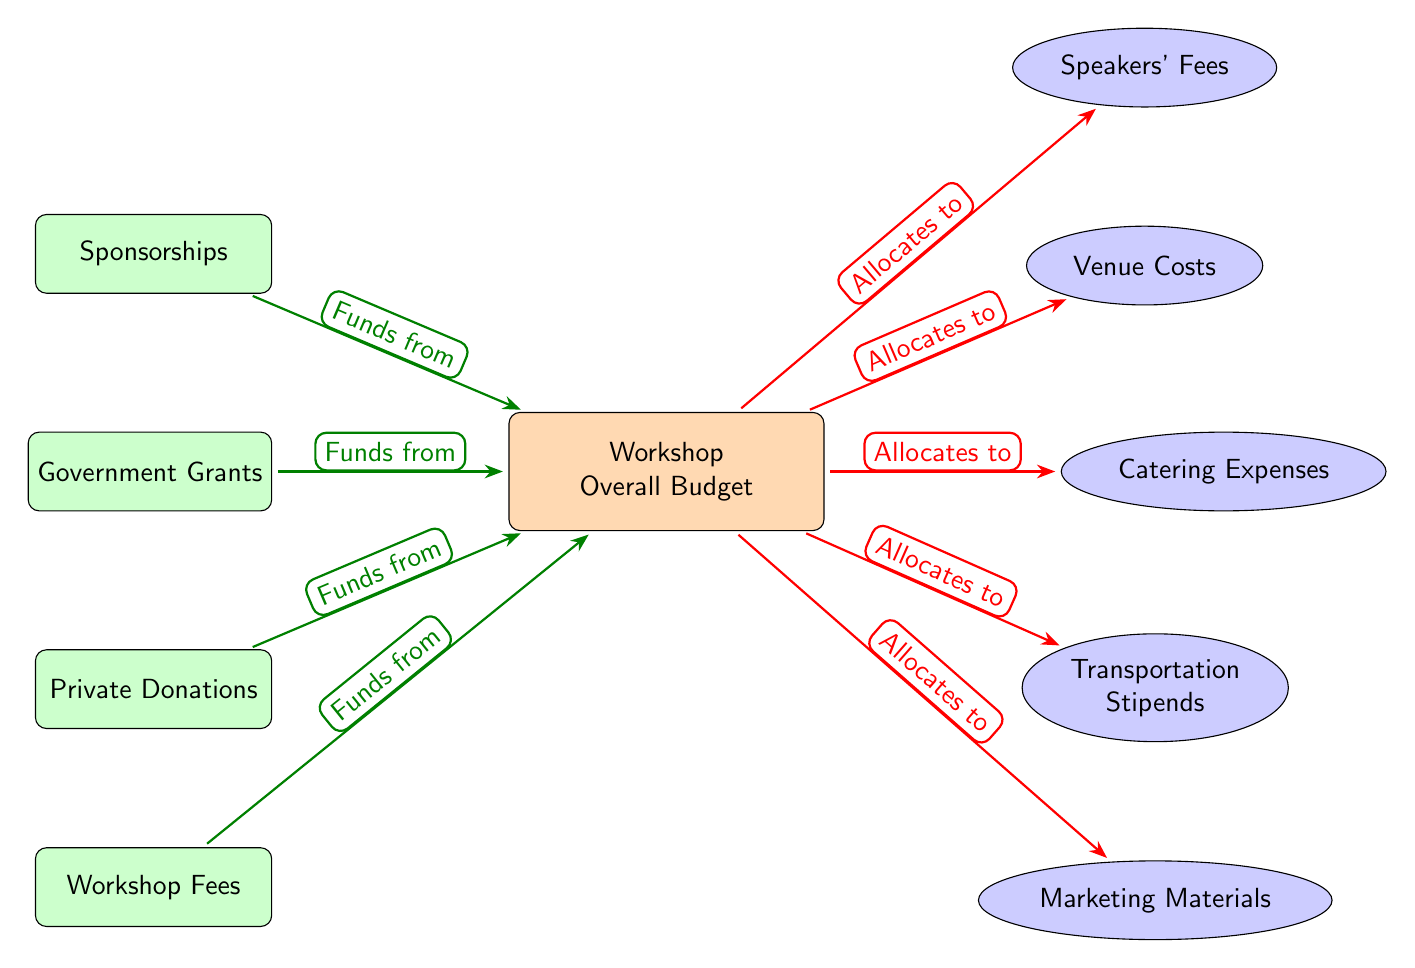What is the central node of the diagram? The central node is labeled "Workshop Overall Budget," indicating the main focus of the diagram, as it organizes the related expenses and income sources surrounding it.
Answer: Workshop Overall Budget How many categories of expenses are shown in the diagram? The diagram displays five categories of expenses, specifically Venue Costs, Catering Expenses, Transportation Stipends, Speakers' Fees, and Marketing Materials, all connected to the central budget node.
Answer: 5 What funding source is associated with Private Donations? Private Donations is an income node that directs funds into the "Workshop Overall Budget," signifying its contribution to the funding of the workshop's expenses.
Answer: Funds from Which expense is located directly above Venue Costs? Speakers' Fees is positioned directly above Venue Costs, indicating that it is a related expense category and is financially allocated from the overall budget.
Answer: Speakers' Fees What color represents the income nodes in the diagram? The income nodes are colored green!20, visually distinguishing them from the expense nodes which are in blue!20; this color coding helps users quickly identify funding sources.
Answer: Green How does the "Government Grants" node interact with the budget? The Government Grants node sends funding to the Workshop Overall Budget, illustrated by an arrow that states "Funds from," indicating the flow of resources necessary for covering workshop expenses.
Answer: Funds from What is the relationship between Marketing Materials and the Workshop Overall Budget? Marketing Materials is an expense that is allocated from the Workshop Overall Budget, showing a financial connection where budget resources are dedicated to acquiring marketing materials for the workshop.
Answer: Allocates to Which expense category is directly below Transportation Stipends? The expense category directly below Transportation Stipends is Marketing Materials; this positioning suggests a structured layout for the expenses associated with the workshop.
Answer: Marketing Materials What type of diagram is this? The diagram is a Textbook Diagram, specifically designed to illustrate the relationships between the budget allocations for expenses and the sources of income in a structured manner.
Answer: Textbook Diagram 